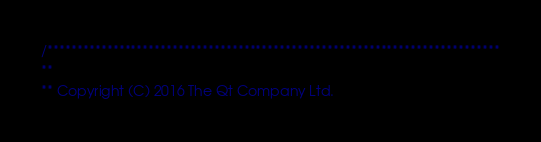<code> <loc_0><loc_0><loc_500><loc_500><_C_>/****************************************************************************
**
** Copyright (C) 2016 The Qt Company Ltd.</code> 